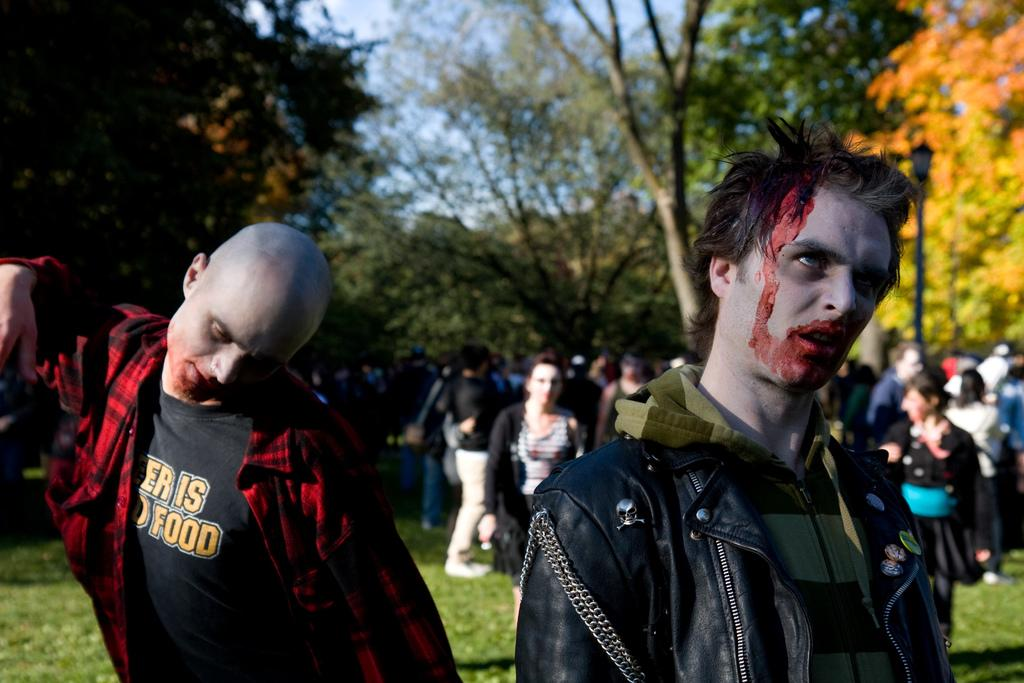Who or what can be seen in the image? There are people in the image. What type of natural environment is visible in the image? There is grass and trees visible in the image. What else can be seen in the image besides the people and natural environment? The sky is visible in the image. What type of tub is visible in the image? There is no tub present in the image. Can you tell me how many lawyers are participating in the feast in the image? There is no feast or lawyers present in the image. 